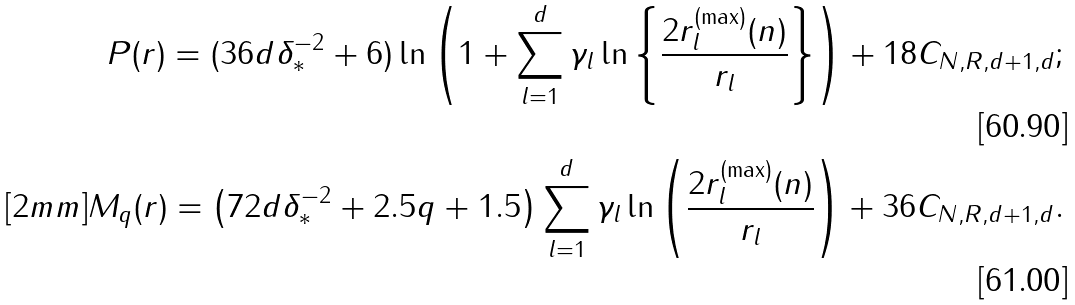<formula> <loc_0><loc_0><loc_500><loc_500>P ( r ) = ( 3 6 d \delta ^ { - 2 } _ { * } + 6 ) \ln { \left ( 1 + \sum _ { l = 1 } ^ { d } \gamma _ { l } \ln { \left \{ \frac { 2 r ^ { ( \max ) } _ { l } ( n ) } { r _ { l } } \right \} } \right ) } + 1 8 C _ { N , R , d + 1 , d } ; \\ [ 2 m m ] M _ { q } ( r ) = \left ( 7 2 d \delta ^ { - 2 } _ { * } + 2 . 5 q + 1 . 5 \right ) \sum _ { l = 1 } ^ { d } \gamma _ { l } \ln { \left ( \frac { 2 r ^ { ( \max ) } _ { l } ( n ) } { r _ { l } } \right ) } + 3 6 C _ { N , R , d + 1 , d } .</formula> 